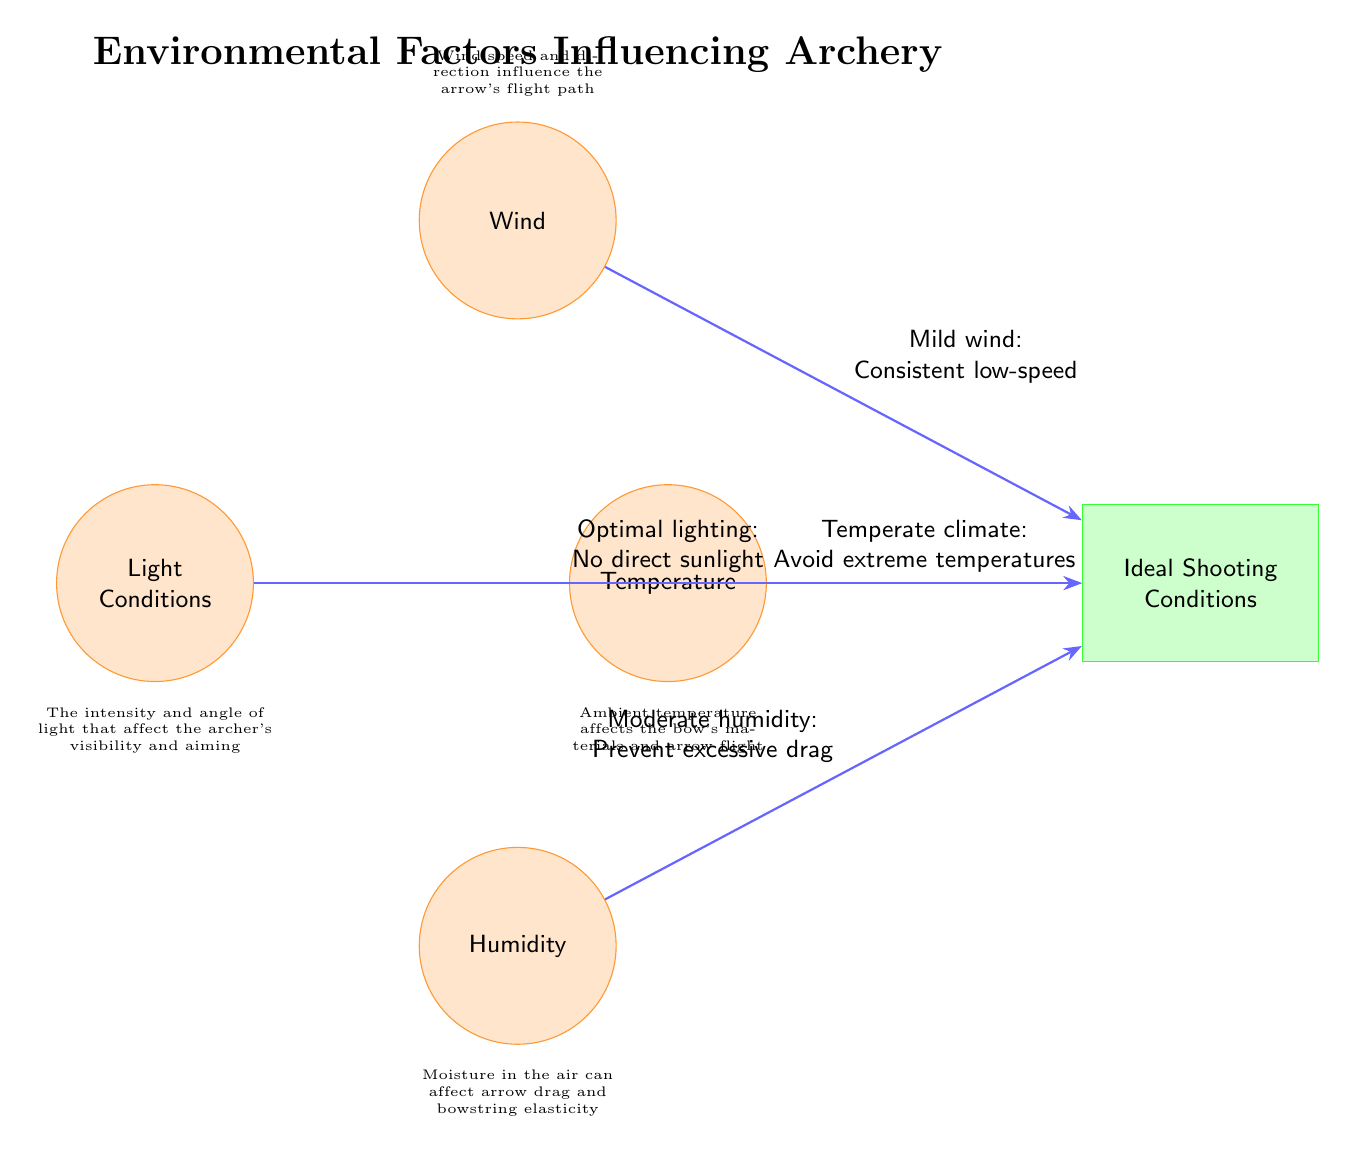What are the four environmental factors depicted in the diagram? The diagram lists four factors: Light Conditions, Wind, Humidity, and Temperature.
Answer: Light Conditions, Wind, Humidity, Temperature What does mild wind refer to in the ideal shooting conditions? Mild wind is described as having a consistent low-speed, which is beneficial for maintaining the arrow's flight path.
Answer: Consistent low-speed What type of lighting is optimal according to the diagram? The diagram states that optimal lighting is when there is no direct sunlight, which helps improve visibility for the archer.
Answer: No direct sunlight How many nodes are depicted in the diagram? There are five nodes total: four environmental factors and one ideal shooting conditions node.
Answer: 5 What does moderate humidity prevent according to the diagram? Moderate humidity is stated in the diagram to prevent excessive drag on the arrow during flight.
Answer: Excessive drag Why is temperature control important for archery performance? Ambient temperature affects the materials of the bow and the flight characteristics of the arrow, making it important to avoid extremes.
Answer: Avoid extreme temperatures What relationship exists between humidity and ideal shooting conditions? Humidity impacts shooting performance by influencing the drag on arrows; thus moderate humidity helps achieve ideal conditions.
Answer: Prevent excessive drag What node is the final destination for all arrows pointing towards environmental factors? The arrows from all the environmental factors point towards the node labeled Ideal Shooting Conditions, indicating the favorable outcomes from those factors.
Answer: Ideal Shooting Conditions 